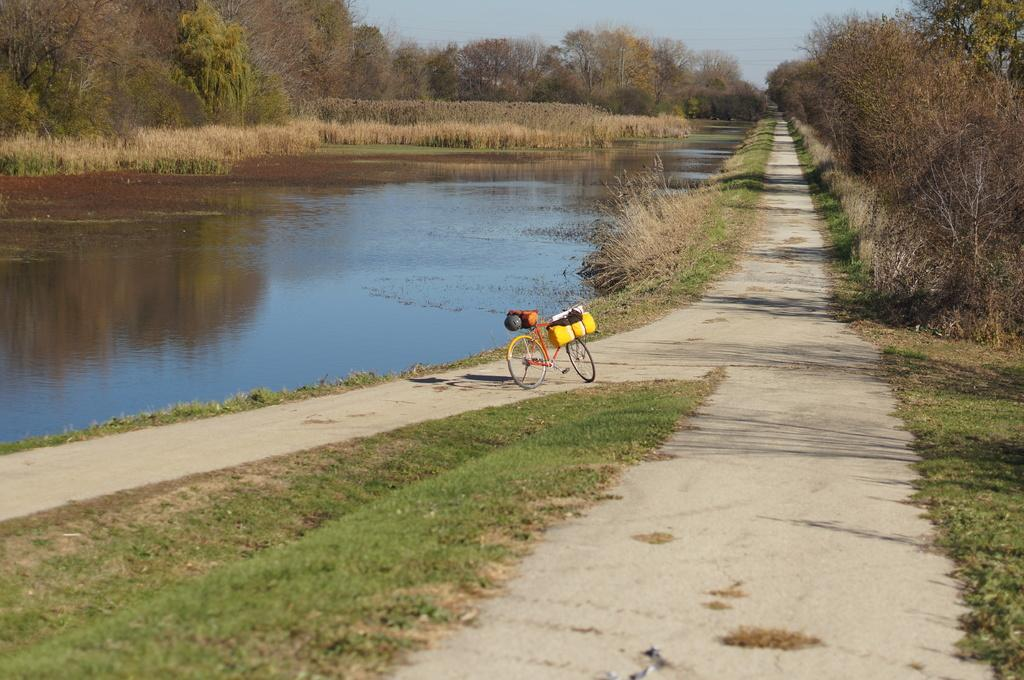What is the main object in the image? There is a bicycle in the image. What type of terrain is visible at the bottom of the image? There is grass at the bottom of the image. What can be seen on the left side of the image? There is water on the left side of the image. What type of vegetation is present in the image? There are trees in the image. What is visible at the top of the image? The sky is visible at the top of the image. What type of stew is being cooked in the image? There is no stew present in the image; it features a bicycle, grass, water, trees, and the sky. What scent can be detected in the image? There is no mention of a scent in the image, as it focuses on visual elements such as the bicycle, grass, water, trees, and sky. 